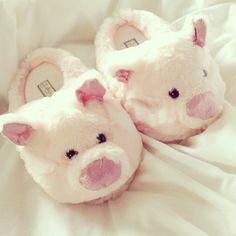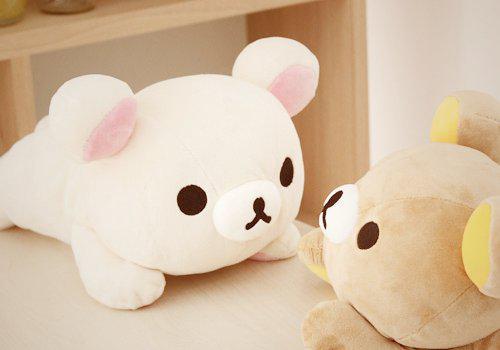The first image is the image on the left, the second image is the image on the right. Considering the images on both sides, is "there are two pair of punny slippers in the image pair" valid? Answer yes or no. No. 